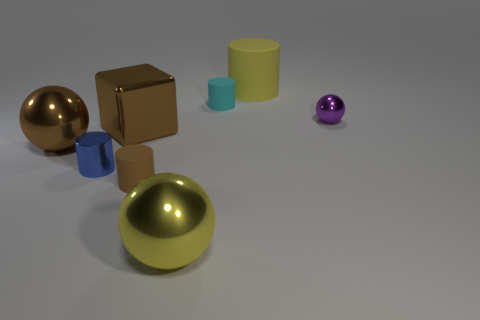Subtract all cyan cylinders. How many cylinders are left? 3 Subtract all small balls. How many balls are left? 2 Subtract 1 cylinders. How many cylinders are left? 3 Subtract all gray cylinders. Subtract all cyan balls. How many cylinders are left? 4 Add 1 big yellow things. How many objects exist? 9 Subtract 0 blue blocks. How many objects are left? 8 Subtract all spheres. How many objects are left? 5 Subtract all purple balls. Subtract all yellow shiny balls. How many objects are left? 6 Add 1 small brown cylinders. How many small brown cylinders are left? 2 Add 7 large brown cylinders. How many large brown cylinders exist? 7 